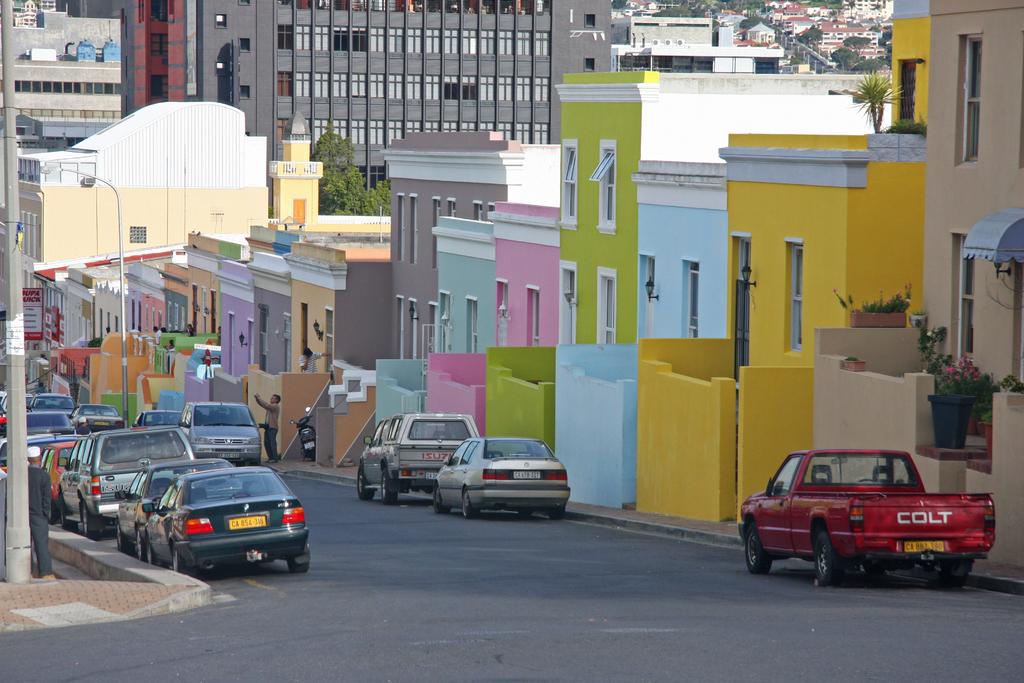What brand is the red truck?
Offer a very short reply. Colt. 